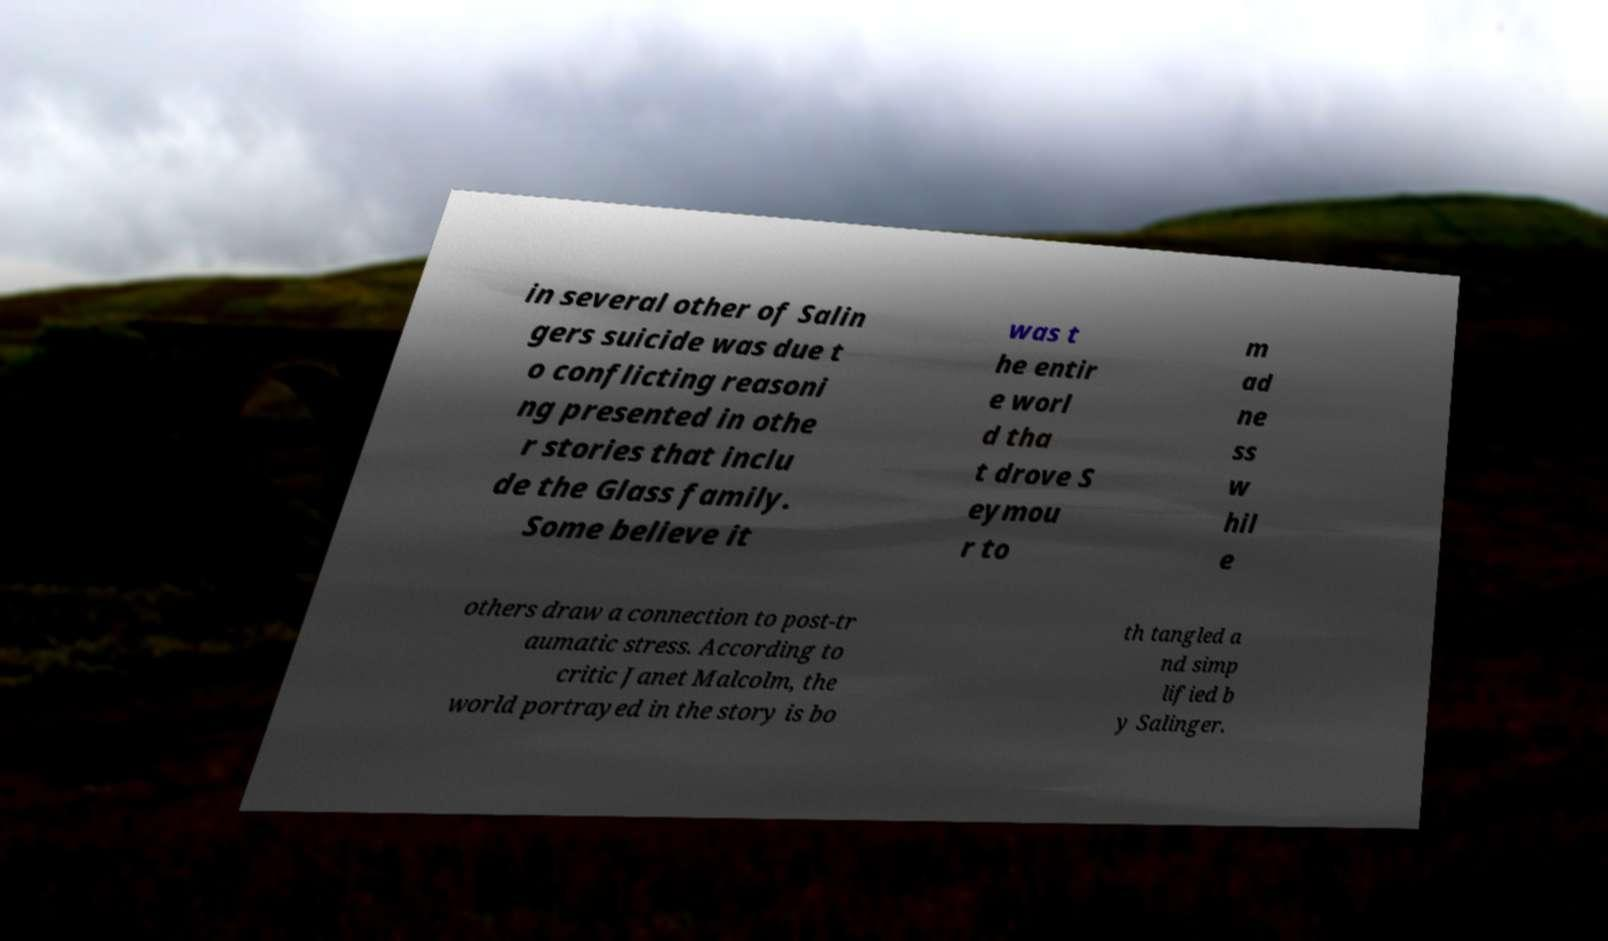Please identify and transcribe the text found in this image. in several other of Salin gers suicide was due t o conflicting reasoni ng presented in othe r stories that inclu de the Glass family. Some believe it was t he entir e worl d tha t drove S eymou r to m ad ne ss w hil e others draw a connection to post-tr aumatic stress. According to critic Janet Malcolm, the world portrayed in the story is bo th tangled a nd simp lified b y Salinger. 